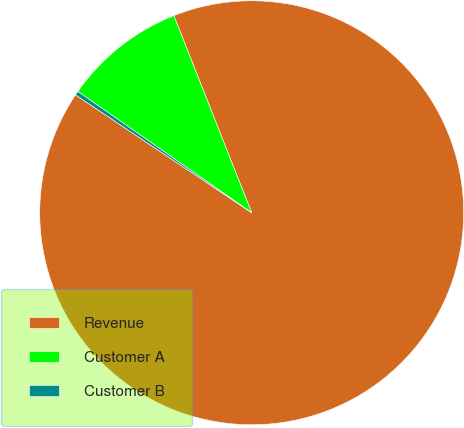<chart> <loc_0><loc_0><loc_500><loc_500><pie_chart><fcel>Revenue<fcel>Customer A<fcel>Customer B<nl><fcel>90.37%<fcel>9.32%<fcel>0.31%<nl></chart> 